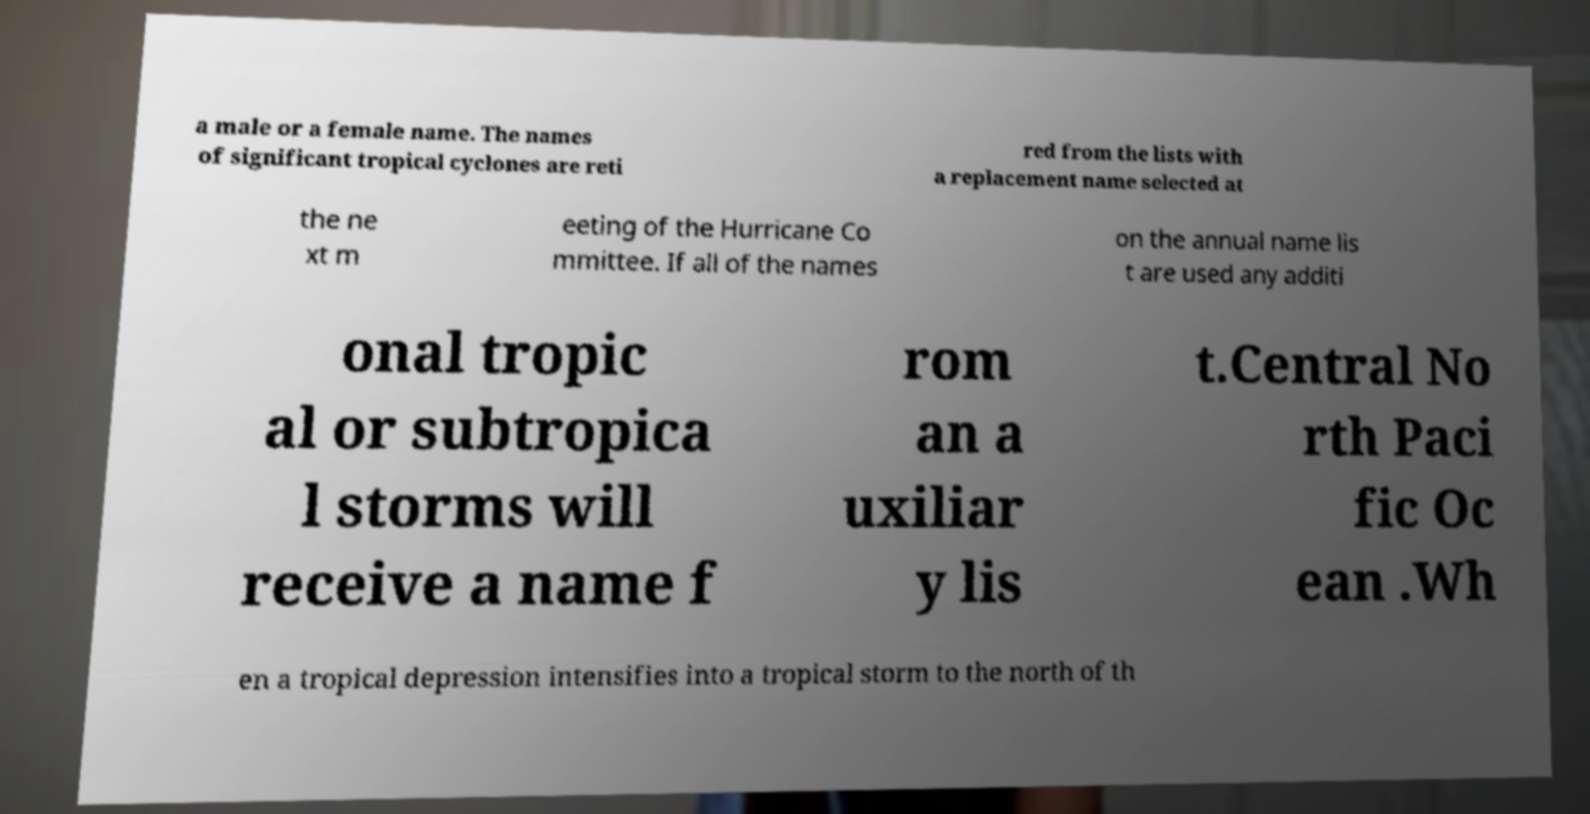Please identify and transcribe the text found in this image. a male or a female name. The names of significant tropical cyclones are reti red from the lists with a replacement name selected at the ne xt m eeting of the Hurricane Co mmittee. If all of the names on the annual name lis t are used any additi onal tropic al or subtropica l storms will receive a name f rom an a uxiliar y lis t.Central No rth Paci fic Oc ean .Wh en a tropical depression intensifies into a tropical storm to the north of th 